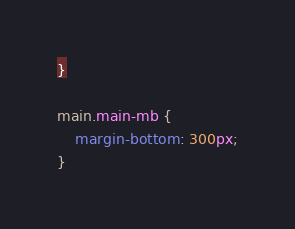Convert code to text. <code><loc_0><loc_0><loc_500><loc_500><_CSS_>}

main.main-mb {
    margin-bottom: 300px;
}</code> 